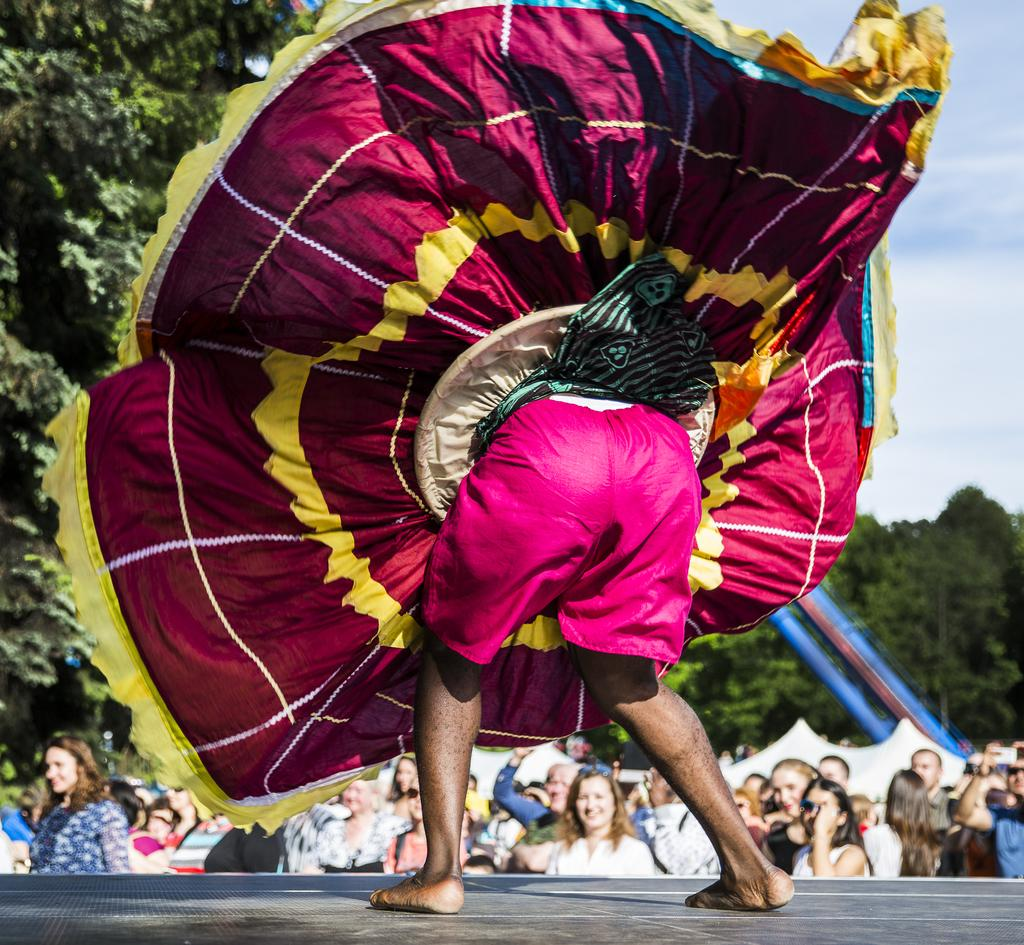What is happening on the stage in the image? There is a person on the stage in the image. What is the person wearing? The person is wearing a costume. What can be seen in the background of the image? There are trees, tents, and people visible in the background of the image. What is visible at the top of the image? The sky is visible at the top of the image. What type of engine is powering the kettle in the image? There is no engine or kettle present in the image. What reward is the person on stage receiving for their performance? The image does not show any rewards being given, so it cannot be determined from the image. 